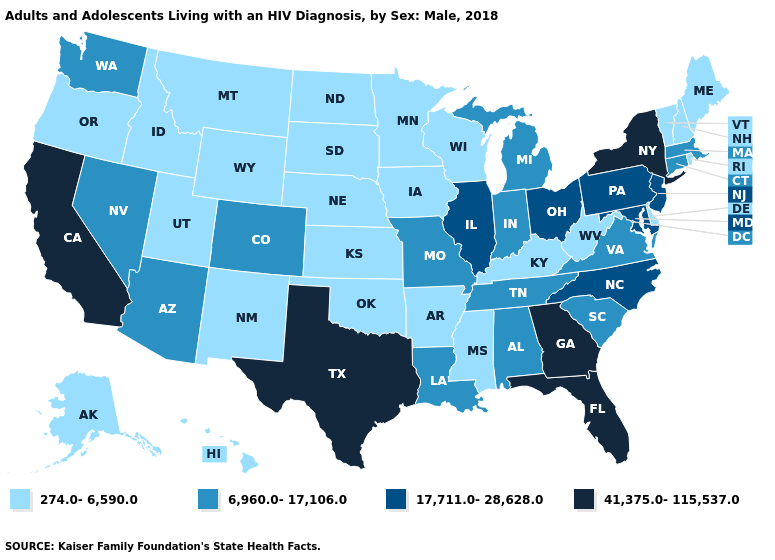Does Vermont have the lowest value in the USA?
Keep it brief. Yes. What is the value of Wisconsin?
Be succinct. 274.0-6,590.0. What is the value of Wyoming?
Short answer required. 274.0-6,590.0. What is the value of Wyoming?
Quick response, please. 274.0-6,590.0. Name the states that have a value in the range 274.0-6,590.0?
Give a very brief answer. Alaska, Arkansas, Delaware, Hawaii, Idaho, Iowa, Kansas, Kentucky, Maine, Minnesota, Mississippi, Montana, Nebraska, New Hampshire, New Mexico, North Dakota, Oklahoma, Oregon, Rhode Island, South Dakota, Utah, Vermont, West Virginia, Wisconsin, Wyoming. Among the states that border New Mexico , does Utah have the lowest value?
Answer briefly. Yes. What is the value of New Jersey?
Short answer required. 17,711.0-28,628.0. Name the states that have a value in the range 274.0-6,590.0?
Be succinct. Alaska, Arkansas, Delaware, Hawaii, Idaho, Iowa, Kansas, Kentucky, Maine, Minnesota, Mississippi, Montana, Nebraska, New Hampshire, New Mexico, North Dakota, Oklahoma, Oregon, Rhode Island, South Dakota, Utah, Vermont, West Virginia, Wisconsin, Wyoming. Which states have the lowest value in the USA?
Write a very short answer. Alaska, Arkansas, Delaware, Hawaii, Idaho, Iowa, Kansas, Kentucky, Maine, Minnesota, Mississippi, Montana, Nebraska, New Hampshire, New Mexico, North Dakota, Oklahoma, Oregon, Rhode Island, South Dakota, Utah, Vermont, West Virginia, Wisconsin, Wyoming. What is the value of Idaho?
Quick response, please. 274.0-6,590.0. Is the legend a continuous bar?
Be succinct. No. What is the value of West Virginia?
Give a very brief answer. 274.0-6,590.0. What is the value of Iowa?
Keep it brief. 274.0-6,590.0. Does Arkansas have the lowest value in the South?
Write a very short answer. Yes. What is the value of Georgia?
Short answer required. 41,375.0-115,537.0. 